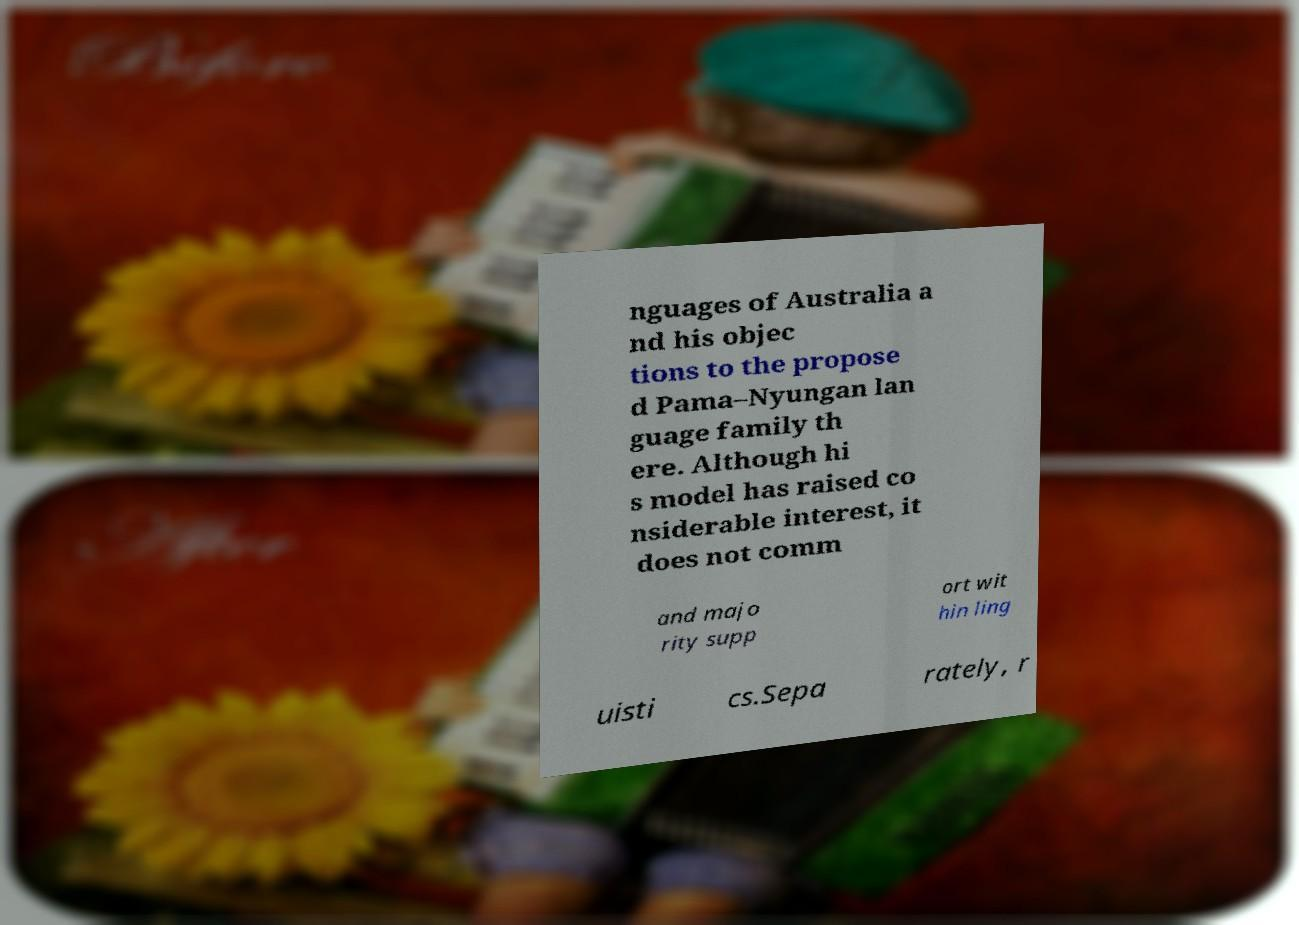I need the written content from this picture converted into text. Can you do that? nguages of Australia a nd his objec tions to the propose d Pama–Nyungan lan guage family th ere. Although hi s model has raised co nsiderable interest, it does not comm and majo rity supp ort wit hin ling uisti cs.Sepa rately, r 